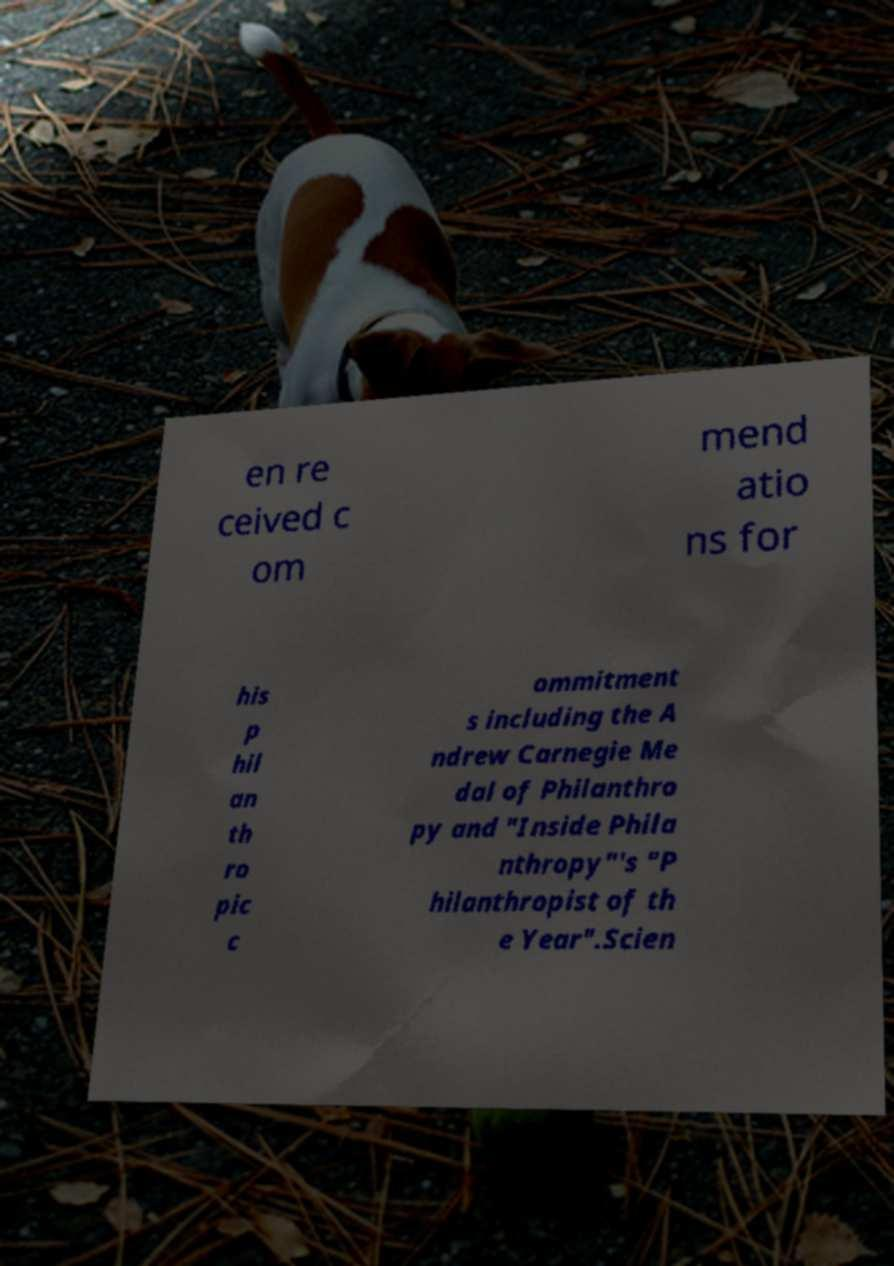Can you accurately transcribe the text from the provided image for me? en re ceived c om mend atio ns for his p hil an th ro pic c ommitment s including the A ndrew Carnegie Me dal of Philanthro py and "Inside Phila nthropy"'s "P hilanthropist of th e Year".Scien 